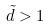<formula> <loc_0><loc_0><loc_500><loc_500>\tilde { d } > 1</formula> 